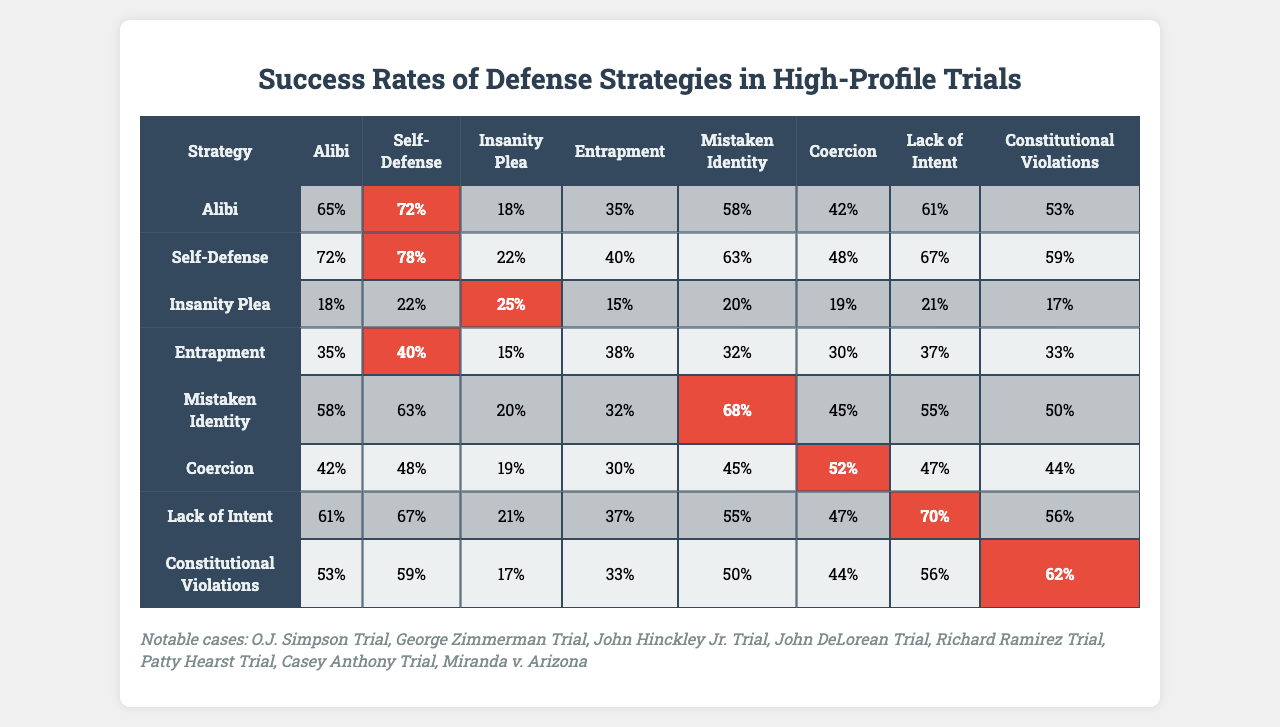What is the highest success rate for the "Self-Defense" strategy? Looking at the "Self-Defense" row in the table, the values corresponding to this strategy are 72%, 78%, 22%, 40%, 63%, 48%, 67%, and 59%. The maximum value among these is 78%.
Answer: 78% Which defense strategy has the lowest overall success rate? By examining the last column that represents the success rates across various strategies, the lowest value is found under "Insanity Plea," which has a maximum value of 25%.
Answer: Insanity Plea What is the success rate of the "Coercion" strategy in the "George Zimmerman Trial"? The "Coercion" strategy corresponds to the second column in the table. The value indicating the success rate for this strategy in the "George Zimmerman Trial" row is 48%.
Answer: 48% What is the average success rate for the "Lack of Intent" strategy across all trials? The success rates for the "Lack of Intent" strategy are 61%, 72%, 21%, 37%, 55%, 47%, 70%, and 56%. Summing these gives (61 + 72 + 21 + 37 + 55 + 47 + 70 + 56) = 419. Dividing by 8 gives 419/8 = 52.375, which we can round to 52.38% for clarity.
Answer: 52.38% Is the success rate of "Mistaken Identity" greater than that of "Entrapment" in high-profile trials? The "Mistaken Identity" strategy has a success rate of 20% in the third column for the "John Hinckley Jr. Trial," while "Entrapment" has a rate of 15% in the same comparison. Since 20% is greater than 15%, the statement is true.
Answer: Yes How many defense strategies have a success rate greater than 65% in the "O.J. Simpson Trial"? Checking the first row for the "O.J. Simpson Trial," we see the success rates: 65%, 72%, 18%, 35%, 58%, 42%, 61%, 53%. The only strategies with rates above 65% are "Self-Defense" (72%) and those with a rate of 65% itself. This sums to 2 strategies overall.
Answer: 2 Compare the success rates of "Alibi" and "Coercion" strategies in the "Richard Ramirez Trial." Which one is more effective? Looking at the relevant rows, "Alibi" has a success rate of 58%, while "Coercion" has a success rate of 45% in the "Richard Ramirez Trial." Since 58% is greater than 45%, the "Alibi" strategy is more effective.
Answer: Alibi What is the difference between the highest and lowest success rates for the "Insanity Plea" strategy across all trials? The success rates for the "Insanity Plea" strategy are 18%, 22%, 25%, 15%, 20%, 19%, 21%, and 17%. The maximum value is 25% and the minimum is 15%. The difference is 25% - 15% = 10%.
Answer: 10% Which notable case had the highest success rate for the "Entrapment" strategy? Examining the "Entrapment" values, they correspond to the rows in the table: 35%, 40%, 15%, 38%, 32%, 30%, 37%, and 33%. The maximum is 40%, which corresponds to the "George Zimmerman Trial."
Answer: George Zimmerman Trial In which defense strategy did "Casey Anthony Trial" yield a success rate of 70%? Looking at the values for the "Casey Anthony Trial," the corresponding column is "Lack of Intent," which has a success rate of 70%.
Answer: Lack of Intent 